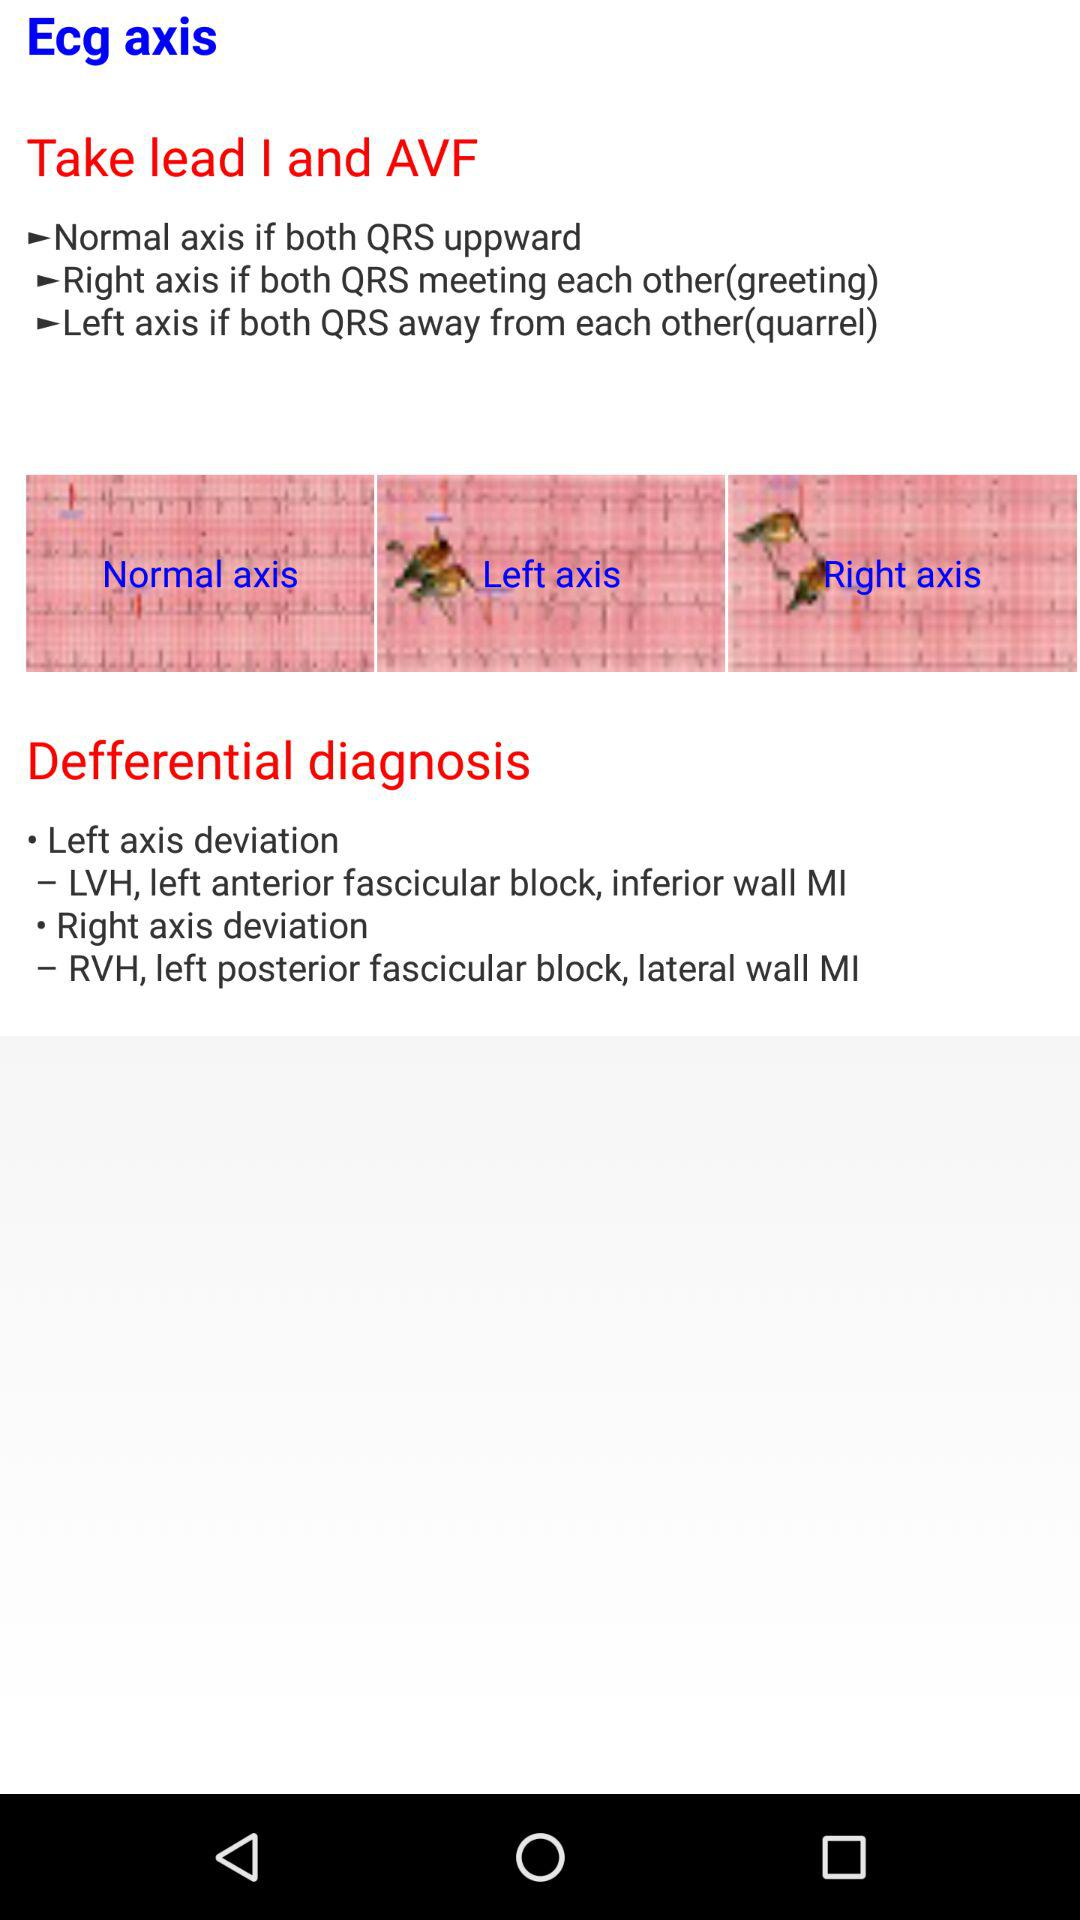How many axis types are there?
Answer the question using a single word or phrase. 3 